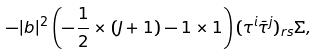<formula> <loc_0><loc_0><loc_500><loc_500>- | b | ^ { 2 } \left ( - \frac { 1 } { 2 } \times ( J + 1 ) - 1 \times 1 \right ) ( \tau ^ { i } \bar { \tau } ^ { j } ) _ { r s } \Sigma ,</formula> 